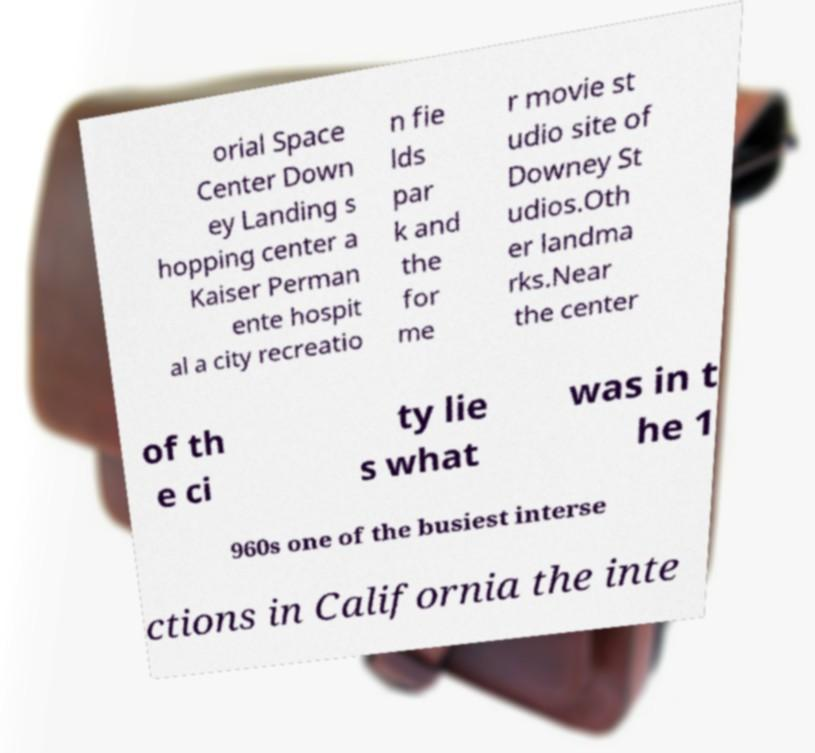Could you assist in decoding the text presented in this image and type it out clearly? orial Space Center Down ey Landing s hopping center a Kaiser Perman ente hospit al a city recreatio n fie lds par k and the for me r movie st udio site of Downey St udios.Oth er landma rks.Near the center of th e ci ty lie s what was in t he 1 960s one of the busiest interse ctions in California the inte 